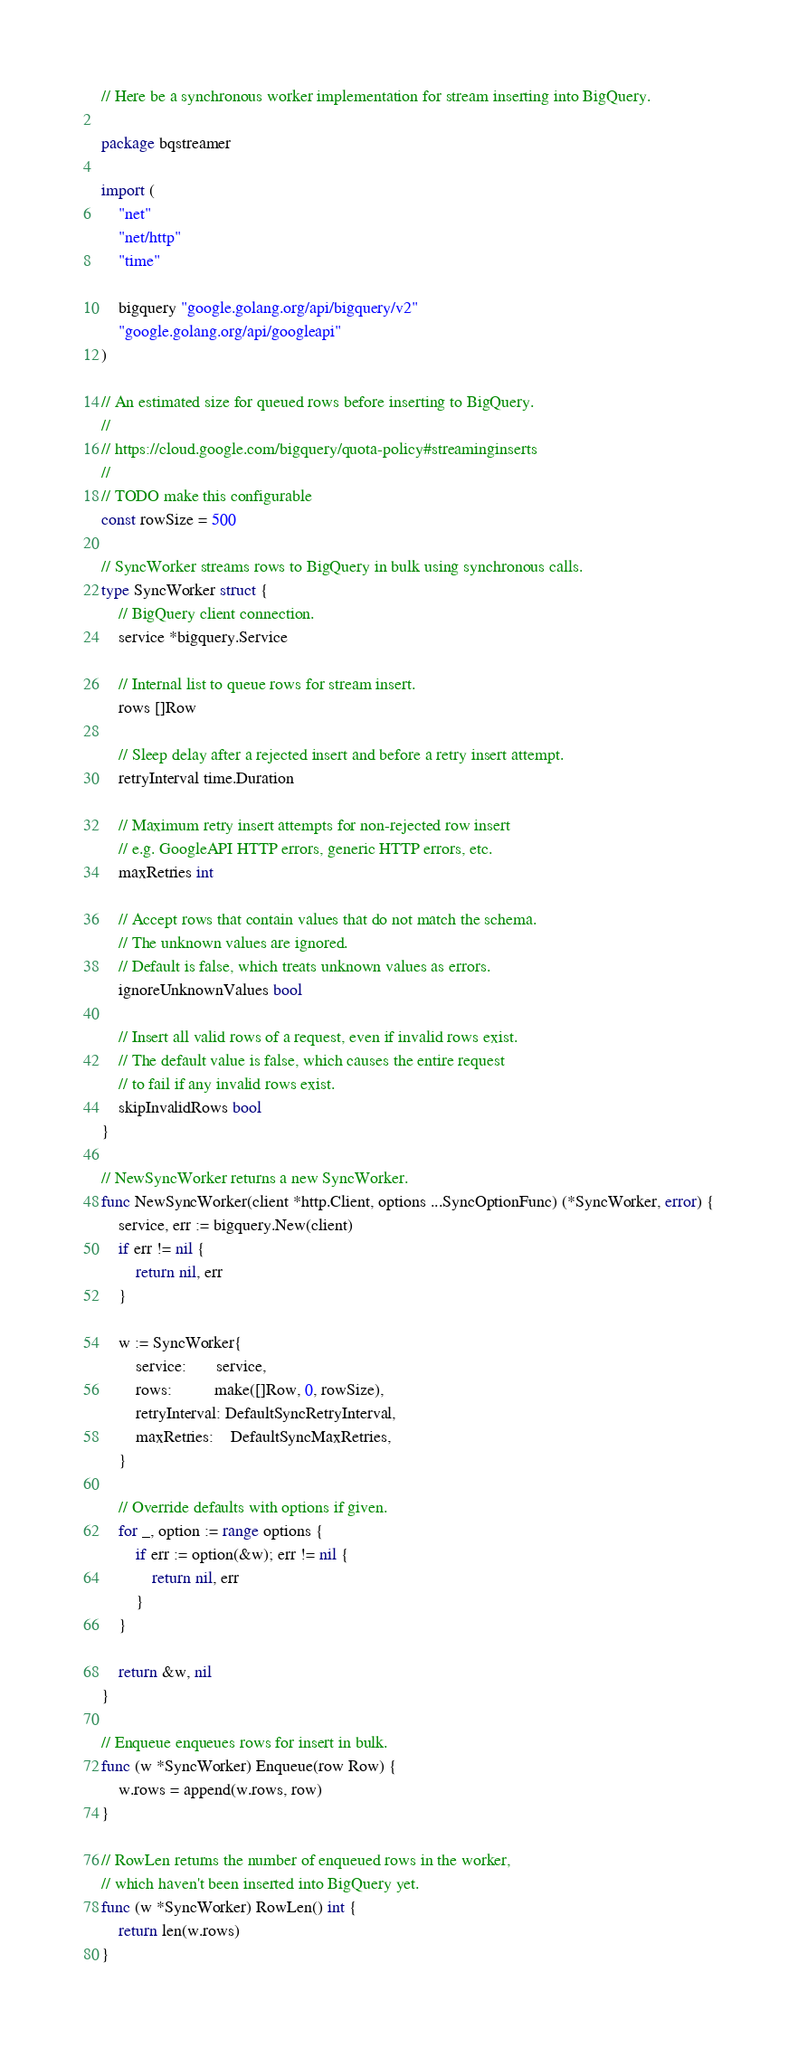<code> <loc_0><loc_0><loc_500><loc_500><_Go_>// Here be a synchronous worker implementation for stream inserting into BigQuery.

package bqstreamer

import (
	"net"
	"net/http"
	"time"

	bigquery "google.golang.org/api/bigquery/v2"
	"google.golang.org/api/googleapi"
)

// An estimated size for queued rows before inserting to BigQuery.
//
// https://cloud.google.com/bigquery/quota-policy#streaminginserts
//
// TODO make this configurable
const rowSize = 500

// SyncWorker streams rows to BigQuery in bulk using synchronous calls.
type SyncWorker struct {
	// BigQuery client connection.
	service *bigquery.Service

	// Internal list to queue rows for stream insert.
	rows []Row

	// Sleep delay after a rejected insert and before a retry insert attempt.
	retryInterval time.Duration

	// Maximum retry insert attempts for non-rejected row insert
	// e.g. GoogleAPI HTTP errors, generic HTTP errors, etc.
	maxRetries int

	// Accept rows that contain values that do not match the schema.
	// The unknown values are ignored.
	// Default is false, which treats unknown values as errors.
	ignoreUnknownValues bool

	// Insert all valid rows of a request, even if invalid rows exist.
	// The default value is false, which causes the entire request
	// to fail if any invalid rows exist.
	skipInvalidRows bool
}

// NewSyncWorker returns a new SyncWorker.
func NewSyncWorker(client *http.Client, options ...SyncOptionFunc) (*SyncWorker, error) {
	service, err := bigquery.New(client)
	if err != nil {
		return nil, err
	}

	w := SyncWorker{
		service:       service,
		rows:          make([]Row, 0, rowSize),
		retryInterval: DefaultSyncRetryInterval,
		maxRetries:    DefaultSyncMaxRetries,
	}

	// Override defaults with options if given.
	for _, option := range options {
		if err := option(&w); err != nil {
			return nil, err
		}
	}

	return &w, nil
}

// Enqueue enqueues rows for insert in bulk.
func (w *SyncWorker) Enqueue(row Row) {
	w.rows = append(w.rows, row)
}

// RowLen returns the number of enqueued rows in the worker,
// which haven't been inserted into BigQuery yet.
func (w *SyncWorker) RowLen() int {
	return len(w.rows)
}
</code> 